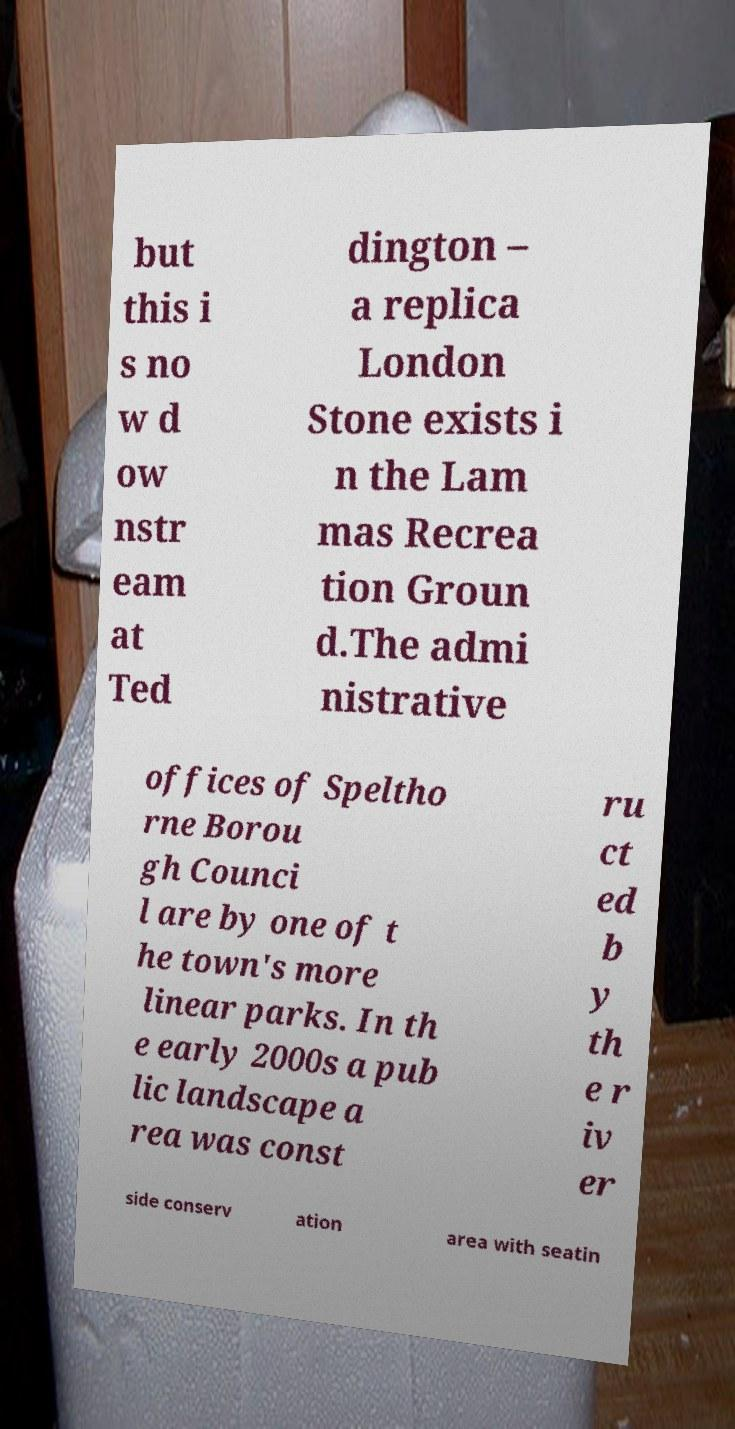Can you read and provide the text displayed in the image?This photo seems to have some interesting text. Can you extract and type it out for me? but this i s no w d ow nstr eam at Ted dington – a replica London Stone exists i n the Lam mas Recrea tion Groun d.The admi nistrative offices of Speltho rne Borou gh Counci l are by one of t he town's more linear parks. In th e early 2000s a pub lic landscape a rea was const ru ct ed b y th e r iv er side conserv ation area with seatin 